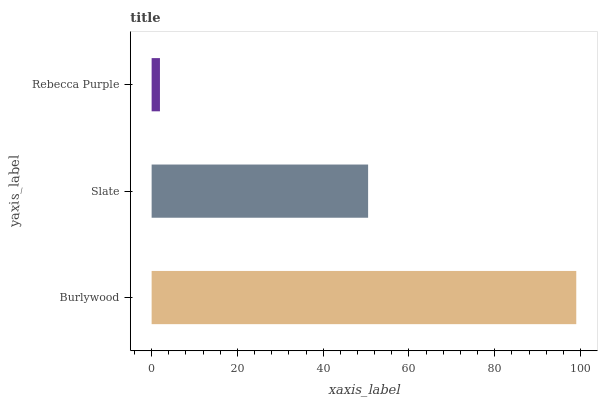Is Rebecca Purple the minimum?
Answer yes or no. Yes. Is Burlywood the maximum?
Answer yes or no. Yes. Is Slate the minimum?
Answer yes or no. No. Is Slate the maximum?
Answer yes or no. No. Is Burlywood greater than Slate?
Answer yes or no. Yes. Is Slate less than Burlywood?
Answer yes or no. Yes. Is Slate greater than Burlywood?
Answer yes or no. No. Is Burlywood less than Slate?
Answer yes or no. No. Is Slate the high median?
Answer yes or no. Yes. Is Slate the low median?
Answer yes or no. Yes. Is Burlywood the high median?
Answer yes or no. No. Is Burlywood the low median?
Answer yes or no. No. 